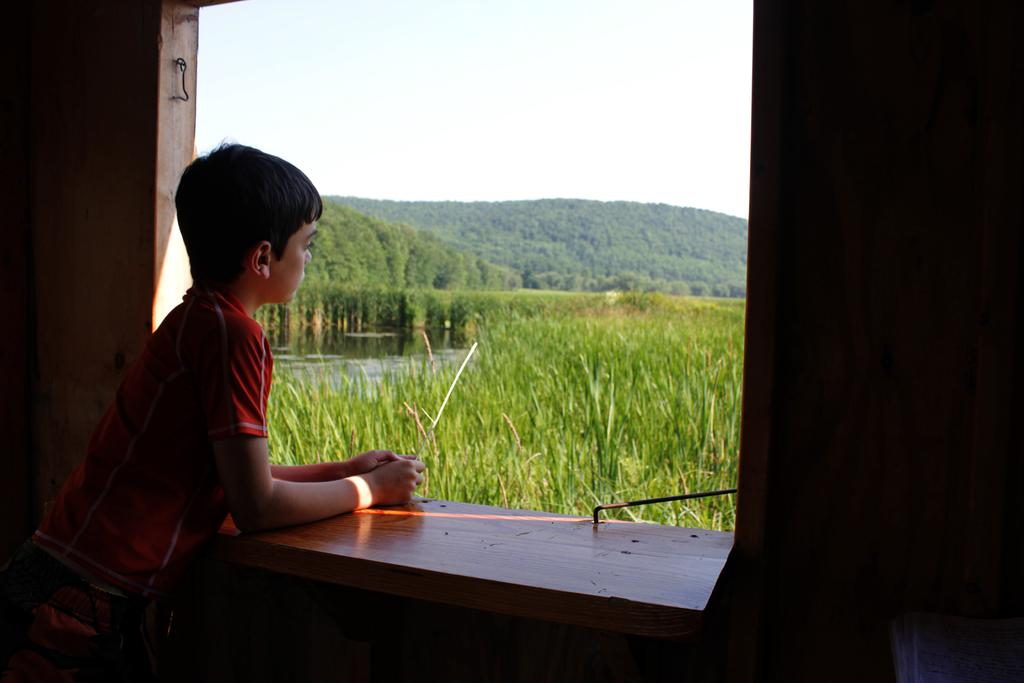What is the person in the image doing? The person is standing near a window. What can be seen in the background of the image? There are hills, fields, and water visible in the background of the image. What type of popcorn is being served at the agreement meeting in the image? There is no mention of popcorn, agreement, or a meeting in the image. The image only shows a person standing near a window with hills, fields, and water in the background. 